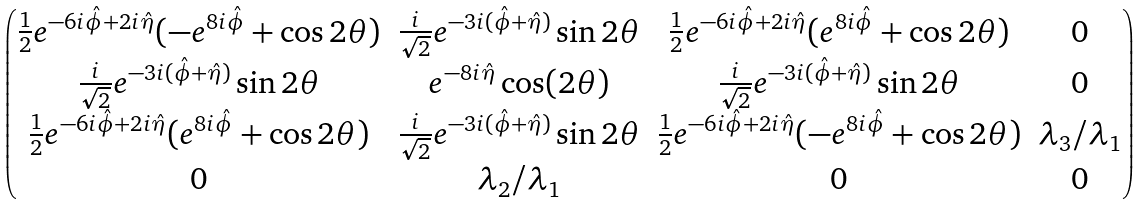<formula> <loc_0><loc_0><loc_500><loc_500>\begin{pmatrix} \frac { 1 } { 2 } e ^ { - 6 i \hat { \phi } + 2 i \hat { \eta } } ( - e ^ { 8 i \hat { \phi } } + \cos 2 \theta ) & \frac { i } { \sqrt { 2 } } e ^ { - 3 i ( \hat { \phi } + \hat { \eta } ) } \sin 2 \theta & \frac { 1 } { 2 } e ^ { - 6 i \hat { \phi } + 2 i \hat { \eta } } ( e ^ { 8 i \hat { \phi } } + \cos 2 \theta ) & 0 \\ \frac { i } { \sqrt { 2 } } e ^ { - 3 i ( \hat { \phi } + \hat { \eta } ) } \sin 2 \theta & e ^ { - 8 i \hat { \eta } } \cos ( 2 \theta ) & \frac { i } { \sqrt { 2 } } e ^ { - 3 i ( \hat { \phi } + \hat { \eta } ) } \sin 2 \theta & 0 \\ \frac { 1 } { 2 } e ^ { - 6 i \hat { \phi } + 2 i \hat { \eta } } ( e ^ { 8 i \hat { \phi } } + \cos 2 \theta ) & \frac { i } { \sqrt { 2 } } e ^ { - 3 i ( \hat { \phi } + \hat { \eta } ) } \sin 2 \theta & \frac { 1 } { 2 } e ^ { - 6 i \hat { \phi } + 2 i \hat { \eta } } ( - e ^ { 8 i \hat { \phi } } + \cos 2 \theta ) & \lambda _ { 3 } / \lambda _ { 1 } \\ 0 & \lambda _ { 2 } / \lambda _ { 1 } & 0 & 0 \end{pmatrix}</formula> 